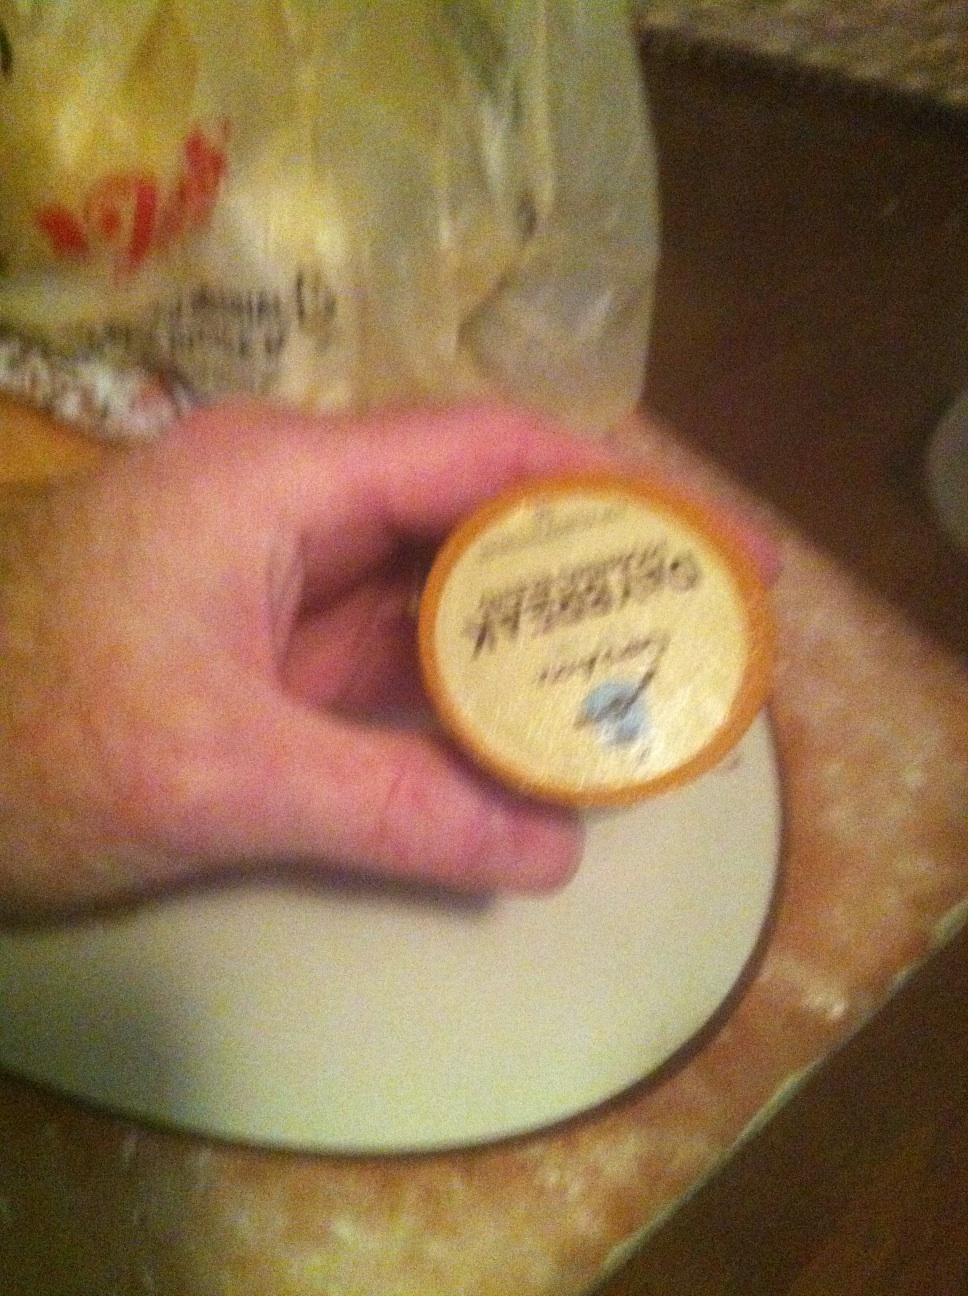What recipe would you recommend using this coffee pod as an ingredient? You can make a delicious coffee-flavored dessert using this coffee pod. Here's a recipe for Coffee Tiramisu:

Ingredients:
- 1 cup brewed strong coffee using the coffee pod
- 1 cup heavy cream
- 1 cup mascarpone cheese
- 1/2 cup sugar
- 1 tsp vanilla extract
- 1 package ladyfinger cookies
- 2 tbsp cocoa powder

Instructions:
1. Brew a cup of strong coffee using the coffee pod. Allow it to cool.
2. In a bowl, whip the heavy cream until stiff peaks form. Set aside.
3. In another bowl, mix the mascarpone cheese, sugar, and vanilla extract until smooth.
4. Gently fold the whipped cream into the mascarpone mixture until combined.
5. Dip each ladyfinger into the cooled coffee and layer them in a dish.
6. Spread half of the mascarpone mixture over the ladyfingers.
7. Repeat with another layer of dipped ladyfingers and the rest of the mascarpone mixture.
8. Dust the top with cocoa powder.
9. Refrigerate for at least 4 hours or overnight before serving.
Enjoy your delightful Coffee Tiramisu! Can you write a short fictional story inspired by this coffee pod's flavor? In the small town of Brewston, there was a cozy café called 'Morning Bliss'. One chilly autumn morning, Mr. Thompson, the café owner, brewed a special blend of coffee using a mysterious coffee pod he had found in a quaint little shop. As the rich, aromatic scent filled the café, customers were drawn in like moths to a flame. Among them was a young writer named Emma, struggling with a severe case of writer's block. She ordered a cup of the new blend, hoping the caffeine would spark some inspiration. As she sipped the smooth, flavorful coffee, she felt a warmth spread through her, not just from the drink, but from a newfound sense of clarity. Suddenly, the words flowed effortlessly from her pen. That coffee pod had a way of awakening not just taste buds, but also the deeper inklings of creativity buried within the soul. From then on, Emma frequented 'Morning Bliss,' penning novels and stories that captivated readers far and wide, all thanks to the magical brew that had kindled her imagination. 